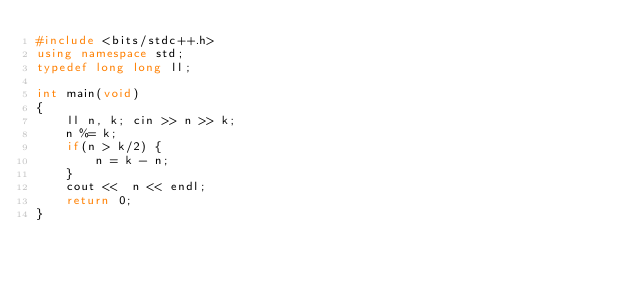<code> <loc_0><loc_0><loc_500><loc_500><_C++_>#include <bits/stdc++.h>
using namespace std;
typedef long long ll;

int main(void)
{
	ll n, k; cin >> n >> k;
	n %= k;
	if(n > k/2) {
		n = k - n;
	}
	cout <<  n << endl;
	return 0;
}</code> 